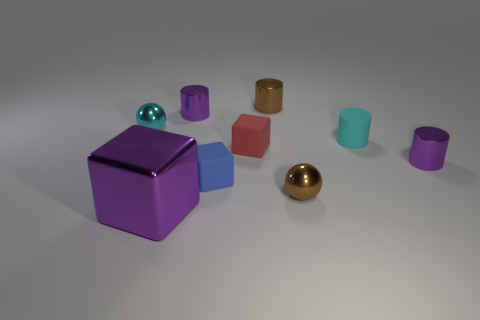Subtract 1 cylinders. How many cylinders are left? 3 Subtract all small brown shiny cylinders. How many cylinders are left? 3 Subtract all green cylinders. Subtract all yellow balls. How many cylinders are left? 4 Add 1 tiny cyan balls. How many objects exist? 10 Subtract all blocks. How many objects are left? 6 Add 8 rubber cylinders. How many rubber cylinders exist? 9 Subtract 0 red cylinders. How many objects are left? 9 Subtract all brown metallic objects. Subtract all small blocks. How many objects are left? 5 Add 1 tiny red cubes. How many tiny red cubes are left? 2 